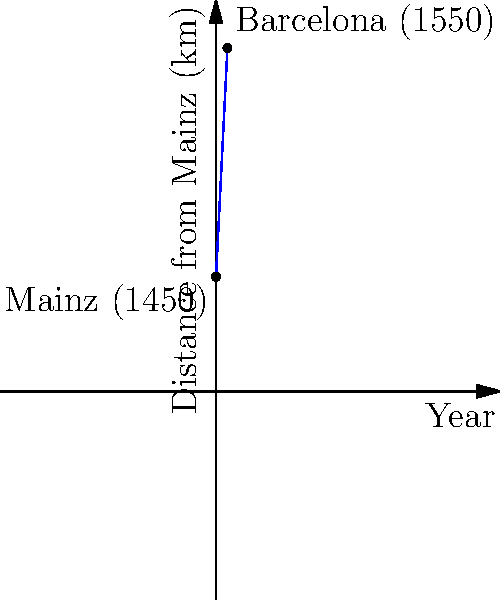The graph represents the spread of printed materials from Mainz, Germany (the birthplace of the printing press) to Barcelona over a century. Given that Mainz is represented by the point (0, 100) and Barcelona by (10, 300), where the x-axis represents decades since 1450 and the y-axis represents distance in kilometers, what is the equation of the line representing this spread? What does the slope of this line represent in the context of print history? To find the equation of the line, we'll use the point-slope form:

1) First, calculate the slope:
   $m = \frac{y_2 - y_1}{x_2 - x_1} = \frac{300 - 100}{10 - 0} = \frac{200}{10} = 20$

2) Use the point-slope form with (0, 100) as the known point:
   $y - y_1 = m(x - x_1)$
   $y - 100 = 20(x - 0)$

3) Simplify:
   $y - 100 = 20x$
   $y = 20x + 100$

This is the equation of the line in slope-intercept form.

The slope, 20, represents the rate at which printed materials spread across Europe. In this context, it means that for each decade (x-unit) that passed, the reach of printed materials extended by approximately 20 kilometers.

The y-intercept, 100, represents the initial distance from the origin (in this case, a point 100 km from Mainz) where the spread of printed materials began in 1450.
Answer: $y = 20x + 100$; The slope (20) represents the spread rate of 20 km per decade. 